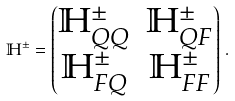<formula> <loc_0><loc_0><loc_500><loc_500>\mathbb { H } ^ { \pm } = \begin{pmatrix} \mathbb { H } _ { Q Q } ^ { \pm } & \mathbb { H } ^ { \pm } _ { Q F } \\ \mathbb { H } ^ { \pm } _ { F Q } & \mathbb { H } _ { F F } ^ { \pm } \end{pmatrix} \, .</formula> 